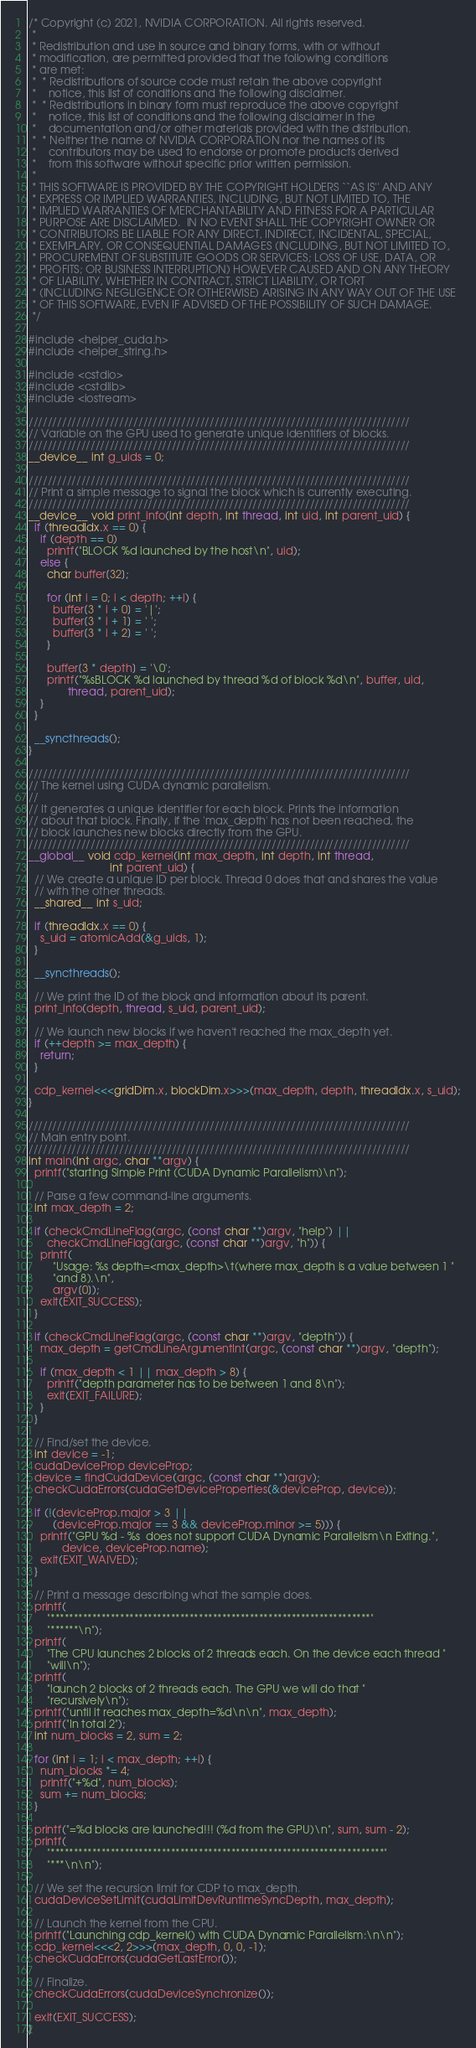Convert code to text. <code><loc_0><loc_0><loc_500><loc_500><_Cuda_>/* Copyright (c) 2021, NVIDIA CORPORATION. All rights reserved.
 *
 * Redistribution and use in source and binary forms, with or without
 * modification, are permitted provided that the following conditions
 * are met:
 *  * Redistributions of source code must retain the above copyright
 *    notice, this list of conditions and the following disclaimer.
 *  * Redistributions in binary form must reproduce the above copyright
 *    notice, this list of conditions and the following disclaimer in the
 *    documentation and/or other materials provided with the distribution.
 *  * Neither the name of NVIDIA CORPORATION nor the names of its
 *    contributors may be used to endorse or promote products derived
 *    from this software without specific prior written permission.
 *
 * THIS SOFTWARE IS PROVIDED BY THE COPYRIGHT HOLDERS ``AS IS'' AND ANY
 * EXPRESS OR IMPLIED WARRANTIES, INCLUDING, BUT NOT LIMITED TO, THE
 * IMPLIED WARRANTIES OF MERCHANTABILITY AND FITNESS FOR A PARTICULAR
 * PURPOSE ARE DISCLAIMED.  IN NO EVENT SHALL THE COPYRIGHT OWNER OR
 * CONTRIBUTORS BE LIABLE FOR ANY DIRECT, INDIRECT, INCIDENTAL, SPECIAL,
 * EXEMPLARY, OR CONSEQUENTIAL DAMAGES (INCLUDING, BUT NOT LIMITED TO,
 * PROCUREMENT OF SUBSTITUTE GOODS OR SERVICES; LOSS OF USE, DATA, OR
 * PROFITS; OR BUSINESS INTERRUPTION) HOWEVER CAUSED AND ON ANY THEORY
 * OF LIABILITY, WHETHER IN CONTRACT, STRICT LIABILITY, OR TORT
 * (INCLUDING NEGLIGENCE OR OTHERWISE) ARISING IN ANY WAY OUT OF THE USE
 * OF THIS SOFTWARE, EVEN IF ADVISED OF THE POSSIBILITY OF SUCH DAMAGE.
 */

#include <helper_cuda.h>
#include <helper_string.h>

#include <cstdio>
#include <cstdlib>
#include <iostream>

////////////////////////////////////////////////////////////////////////////////
// Variable on the GPU used to generate unique identifiers of blocks.
////////////////////////////////////////////////////////////////////////////////
__device__ int g_uids = 0;

////////////////////////////////////////////////////////////////////////////////
// Print a simple message to signal the block which is currently executing.
////////////////////////////////////////////////////////////////////////////////
__device__ void print_info(int depth, int thread, int uid, int parent_uid) {
  if (threadIdx.x == 0) {
    if (depth == 0)
      printf("BLOCK %d launched by the host\n", uid);
    else {
      char buffer[32];

      for (int i = 0; i < depth; ++i) {
        buffer[3 * i + 0] = '|';
        buffer[3 * i + 1] = ' ';
        buffer[3 * i + 2] = ' ';
      }

      buffer[3 * depth] = '\0';
      printf("%sBLOCK %d launched by thread %d of block %d\n", buffer, uid,
             thread, parent_uid);
    }
  }

  __syncthreads();
}

////////////////////////////////////////////////////////////////////////////////
// The kernel using CUDA dynamic parallelism.
//
// It generates a unique identifier for each block. Prints the information
// about that block. Finally, if the 'max_depth' has not been reached, the
// block launches new blocks directly from the GPU.
////////////////////////////////////////////////////////////////////////////////
__global__ void cdp_kernel(int max_depth, int depth, int thread,
                           int parent_uid) {
  // We create a unique ID per block. Thread 0 does that and shares the value
  // with the other threads.
  __shared__ int s_uid;

  if (threadIdx.x == 0) {
    s_uid = atomicAdd(&g_uids, 1);
  }

  __syncthreads();

  // We print the ID of the block and information about its parent.
  print_info(depth, thread, s_uid, parent_uid);

  // We launch new blocks if we haven't reached the max_depth yet.
  if (++depth >= max_depth) {
    return;
  }

  cdp_kernel<<<gridDim.x, blockDim.x>>>(max_depth, depth, threadIdx.x, s_uid);
}

////////////////////////////////////////////////////////////////////////////////
// Main entry point.
////////////////////////////////////////////////////////////////////////////////
int main(int argc, char **argv) {
  printf("starting Simple Print (CUDA Dynamic Parallelism)\n");

  // Parse a few command-line arguments.
  int max_depth = 2;

  if (checkCmdLineFlag(argc, (const char **)argv, "help") ||
      checkCmdLineFlag(argc, (const char **)argv, "h")) {
    printf(
        "Usage: %s depth=<max_depth>\t(where max_depth is a value between 1 "
        "and 8).\n",
        argv[0]);
    exit(EXIT_SUCCESS);
  }

  if (checkCmdLineFlag(argc, (const char **)argv, "depth")) {
    max_depth = getCmdLineArgumentInt(argc, (const char **)argv, "depth");

    if (max_depth < 1 || max_depth > 8) {
      printf("depth parameter has to be between 1 and 8\n");
      exit(EXIT_FAILURE);
    }
  }

  // Find/set the device.
  int device = -1;
  cudaDeviceProp deviceProp;
  device = findCudaDevice(argc, (const char **)argv);
  checkCudaErrors(cudaGetDeviceProperties(&deviceProp, device));

  if (!(deviceProp.major > 3 ||
        (deviceProp.major == 3 && deviceProp.minor >= 5))) {
    printf("GPU %d - %s  does not support CUDA Dynamic Parallelism\n Exiting.",
           device, deviceProp.name);
    exit(EXIT_WAIVED);
  }

  // Print a message describing what the sample does.
  printf(
      "*********************************************************************"
      "******\n");
  printf(
      "The CPU launches 2 blocks of 2 threads each. On the device each thread "
      "will\n");
  printf(
      "launch 2 blocks of 2 threads each. The GPU we will do that "
      "recursively\n");
  printf("until it reaches max_depth=%d\n\n", max_depth);
  printf("In total 2");
  int num_blocks = 2, sum = 2;

  for (int i = 1; i < max_depth; ++i) {
    num_blocks *= 4;
    printf("+%d", num_blocks);
    sum += num_blocks;
  }

  printf("=%d blocks are launched!!! (%d from the GPU)\n", sum, sum - 2);
  printf(
      "************************************************************************"
      "***\n\n");

  // We set the recursion limit for CDP to max_depth.
  cudaDeviceSetLimit(cudaLimitDevRuntimeSyncDepth, max_depth);

  // Launch the kernel from the CPU.
  printf("Launching cdp_kernel() with CUDA Dynamic Parallelism:\n\n");
  cdp_kernel<<<2, 2>>>(max_depth, 0, 0, -1);
  checkCudaErrors(cudaGetLastError());

  // Finalize.
  checkCudaErrors(cudaDeviceSynchronize());

  exit(EXIT_SUCCESS);
}
</code> 